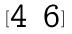<formula> <loc_0><loc_0><loc_500><loc_500>[ \begin{matrix} 4 & 6 \end{matrix} ]</formula> 